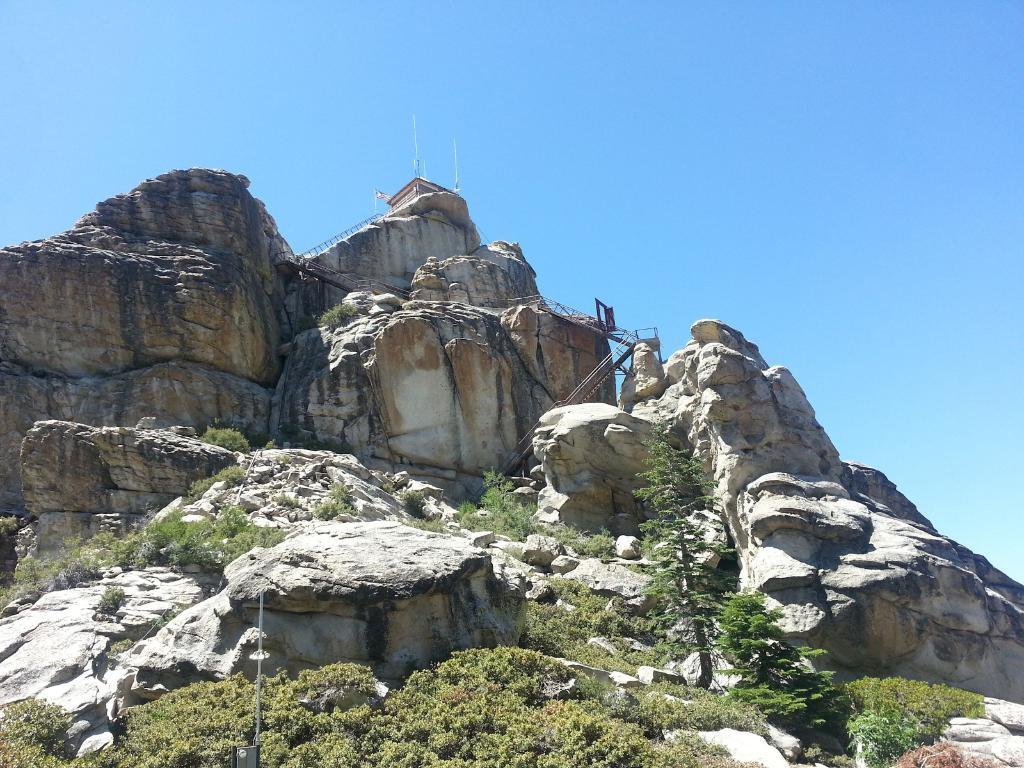What type of geographical feature is present in the image? There are mountains in the image. What can be found on the mountains in the image? There are trees and plants on the mountains in the image. What is visible in the background of the image? There is a sky visible in the background of the image. Can you tell me how many lumberjacks are working in the image? There are no lumberjacks or any indication of logging activity present in the image. What type of animal can be seen grazing on the mountain in the image? There are no animals visible in the image; it only features mountains, trees, plants, and a sky. 